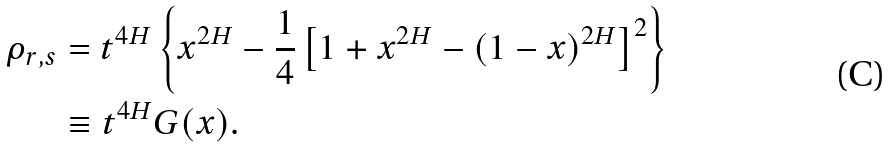<formula> <loc_0><loc_0><loc_500><loc_500>\rho _ { r , s } & = t ^ { 4 H } \left \{ x ^ { 2 H } - \frac { 1 } { 4 } \left [ 1 + x ^ { 2 H } - ( 1 - x ) ^ { 2 H } \right ] ^ { 2 } \right \} \\ & \equiv t ^ { 4 H } G ( x ) .</formula> 